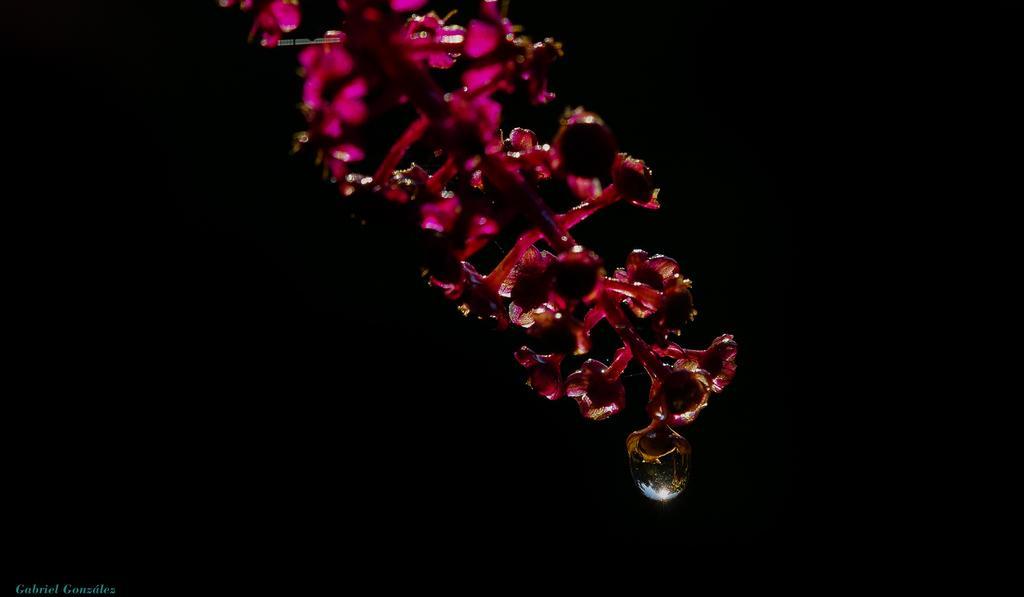Please provide a concise description of this image. In this image we can see a plant and in the background the image is dark. 